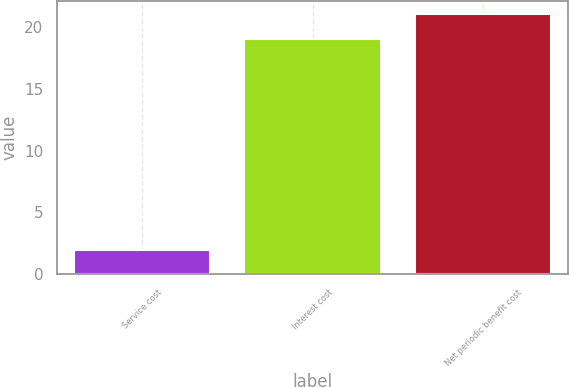<chart> <loc_0><loc_0><loc_500><loc_500><bar_chart><fcel>Service cost<fcel>Interest cost<fcel>Net periodic benefit cost<nl><fcel>2<fcel>19<fcel>21<nl></chart> 